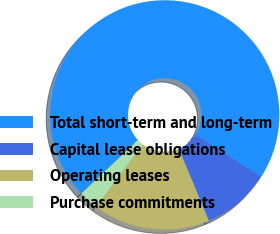Convert chart. <chart><loc_0><loc_0><loc_500><loc_500><pie_chart><fcel>Total short-term and long-term<fcel>Capital lease obligations<fcel>Operating leases<fcel>Purchase commitments<nl><fcel>71.1%<fcel>9.63%<fcel>16.46%<fcel>2.8%<nl></chart> 